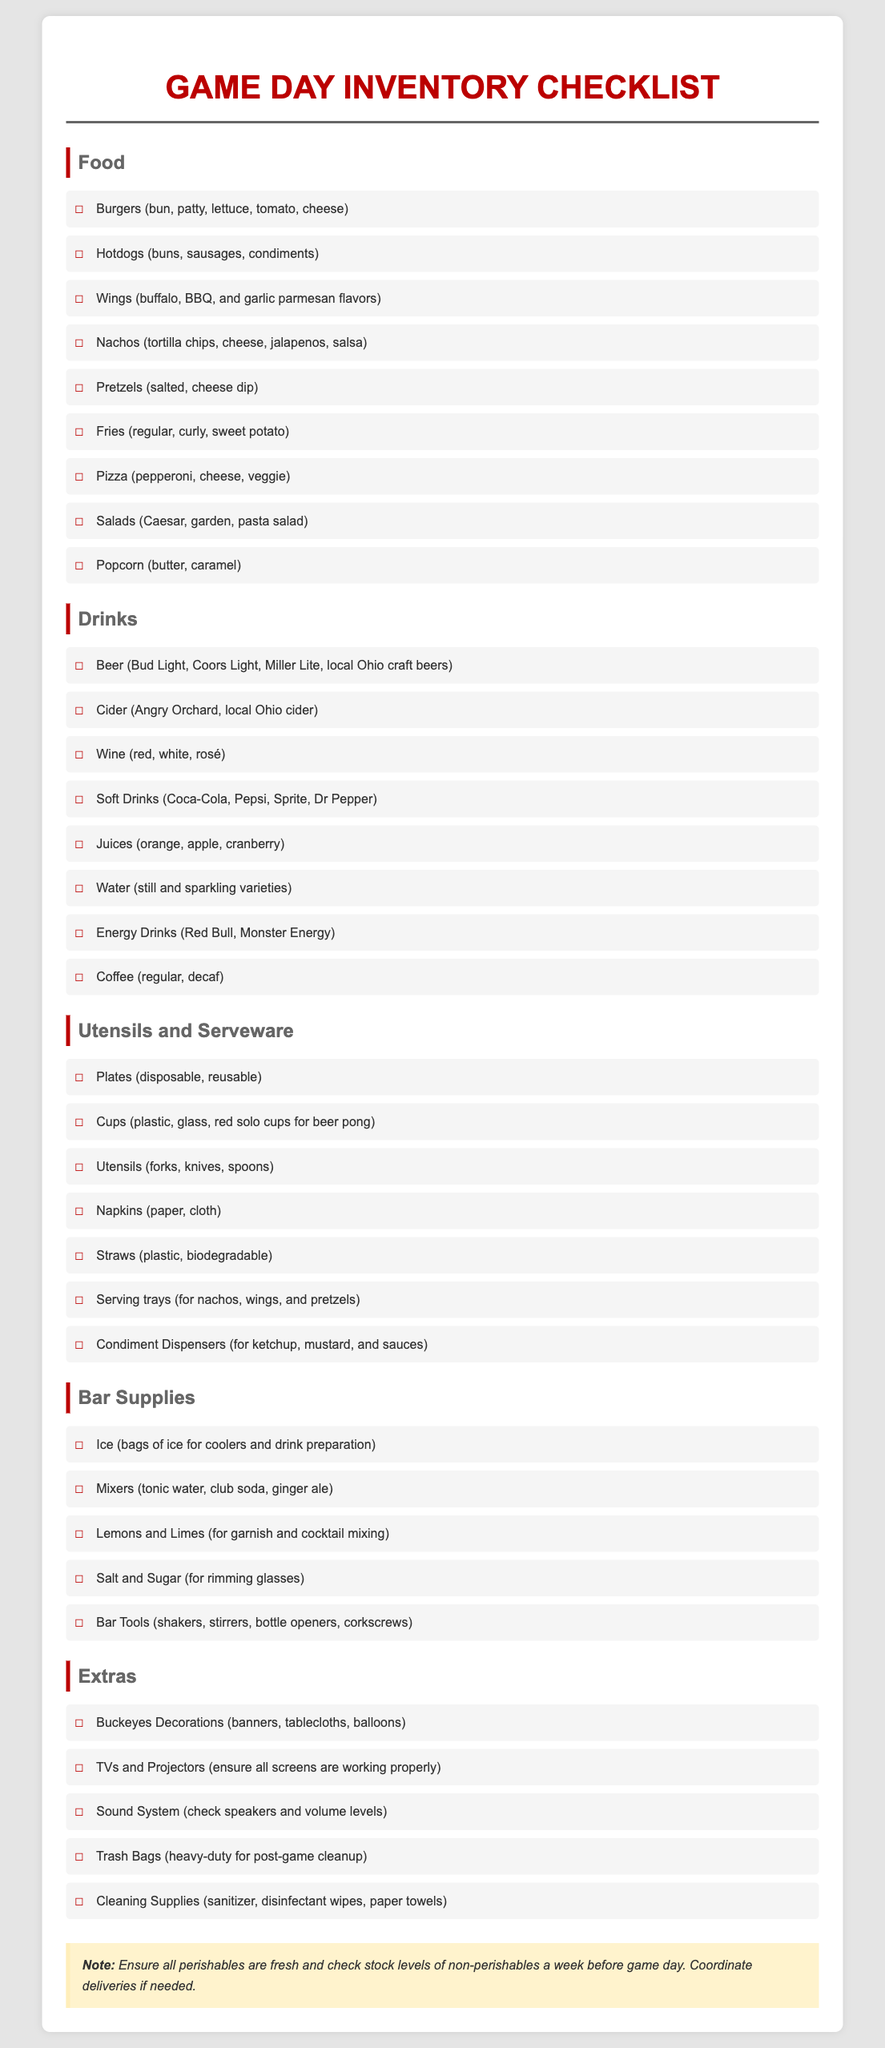What food items are listed for game day? The checklist includes various food items such as burgers, hotdogs, wings, nachos, and more under the Food section.
Answer: Burgers, hotdogs, wings, nachos, pretzels, fries, pizza, salads, popcorn How many drink categories are included in the checklist? The document outlines drink categories such as Beer, Cider, Wine, Soft Drinks, Juices, Water, Energy Drinks, and Coffee.
Answer: Eight What are two types of desserts mentioned in the extras? The checklist does not explicitly mention any desserts under the listed categories, focusing instead on food and drink.
Answer: Not mentioned Which type of utensil is listed for checking inventory? The checklist includes specific utensils needed such as forks, knives, and spoons under the Utensils and Serveware section.
Answer: Forks, knives, spoons What is a suggested decoration mentioned for Buckeye fans? The extras section suggests using Buckeyes decorations such as banners and tablecloths for the game day.
Answer: Banners What should be checked a week before game day? The notes section advises checking stock levels of non-perishables and ensuring perishables are fresh a week before the event.
Answer: Stock levels of non-perishables What is necessary for post-game cleanup? The checklist includes heavy-duty trash bags as part of the extras to aid in post-game cleanup.
Answer: Heavy-duty trash bags How many types of beer are specifically listed? The drinks section specifies several beer options including Bud Light, Coors Light, Miller Lite, and local Ohio craft beers.
Answer: Four 